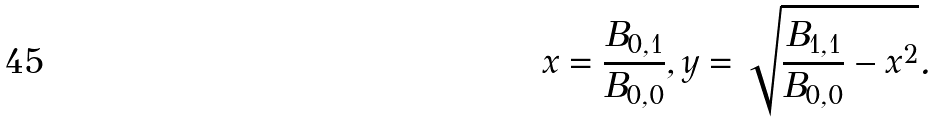Convert formula to latex. <formula><loc_0><loc_0><loc_500><loc_500>x = \frac { B _ { 0 , 1 } } { B _ { 0 , 0 } } , y = \sqrt { \frac { B _ { 1 , 1 } } { B _ { 0 , 0 } } - x ^ { 2 } } .</formula> 